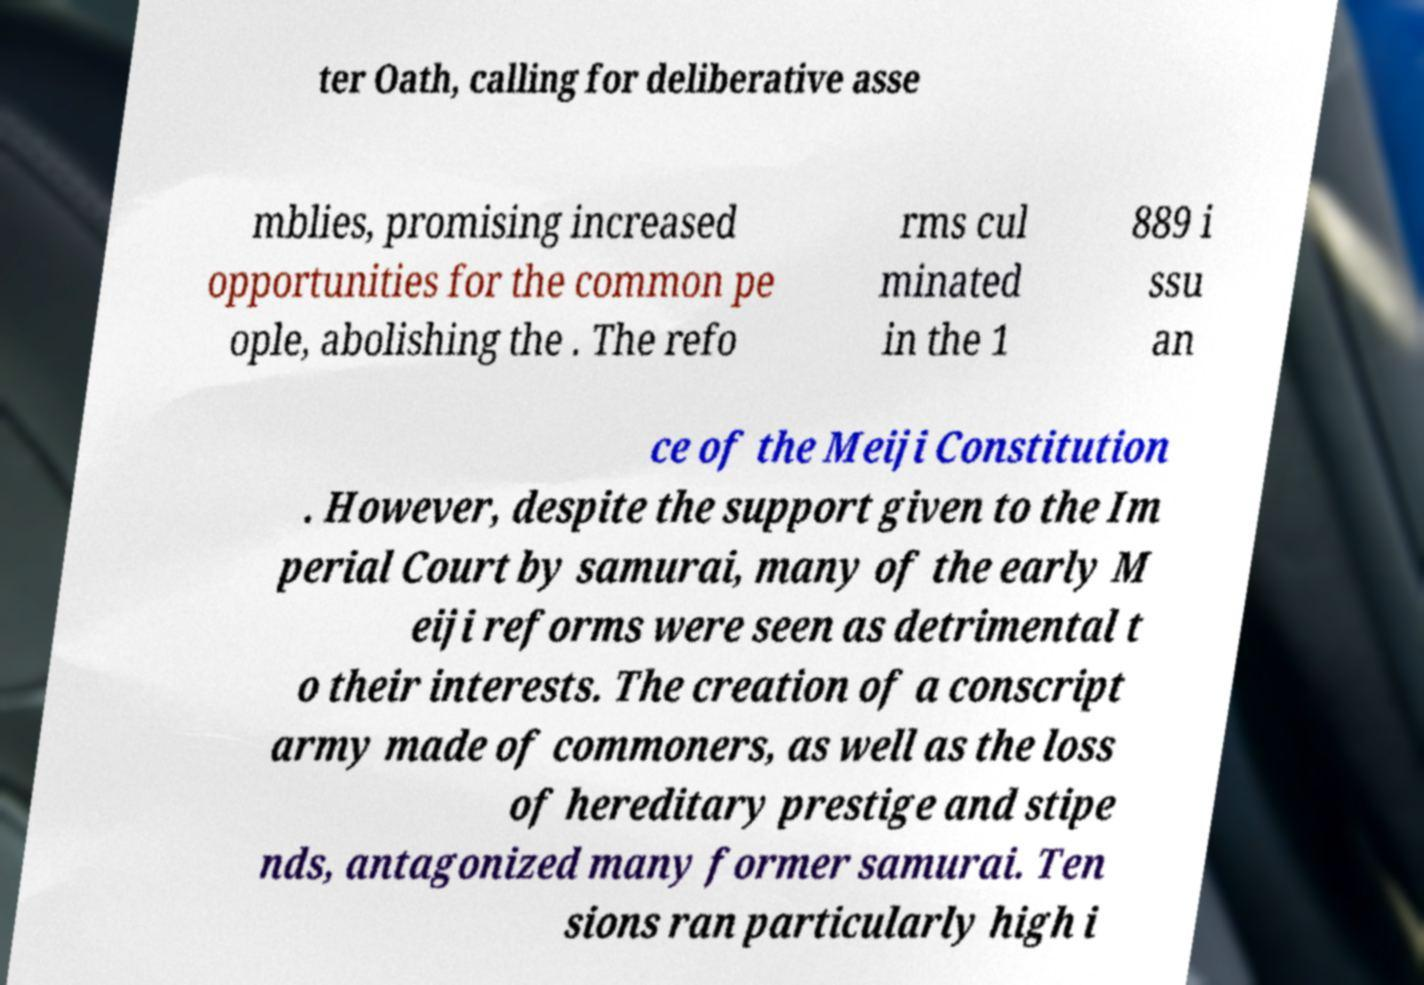Can you read and provide the text displayed in the image?This photo seems to have some interesting text. Can you extract and type it out for me? ter Oath, calling for deliberative asse mblies, promising increased opportunities for the common pe ople, abolishing the . The refo rms cul minated in the 1 889 i ssu an ce of the Meiji Constitution . However, despite the support given to the Im perial Court by samurai, many of the early M eiji reforms were seen as detrimental t o their interests. The creation of a conscript army made of commoners, as well as the loss of hereditary prestige and stipe nds, antagonized many former samurai. Ten sions ran particularly high i 